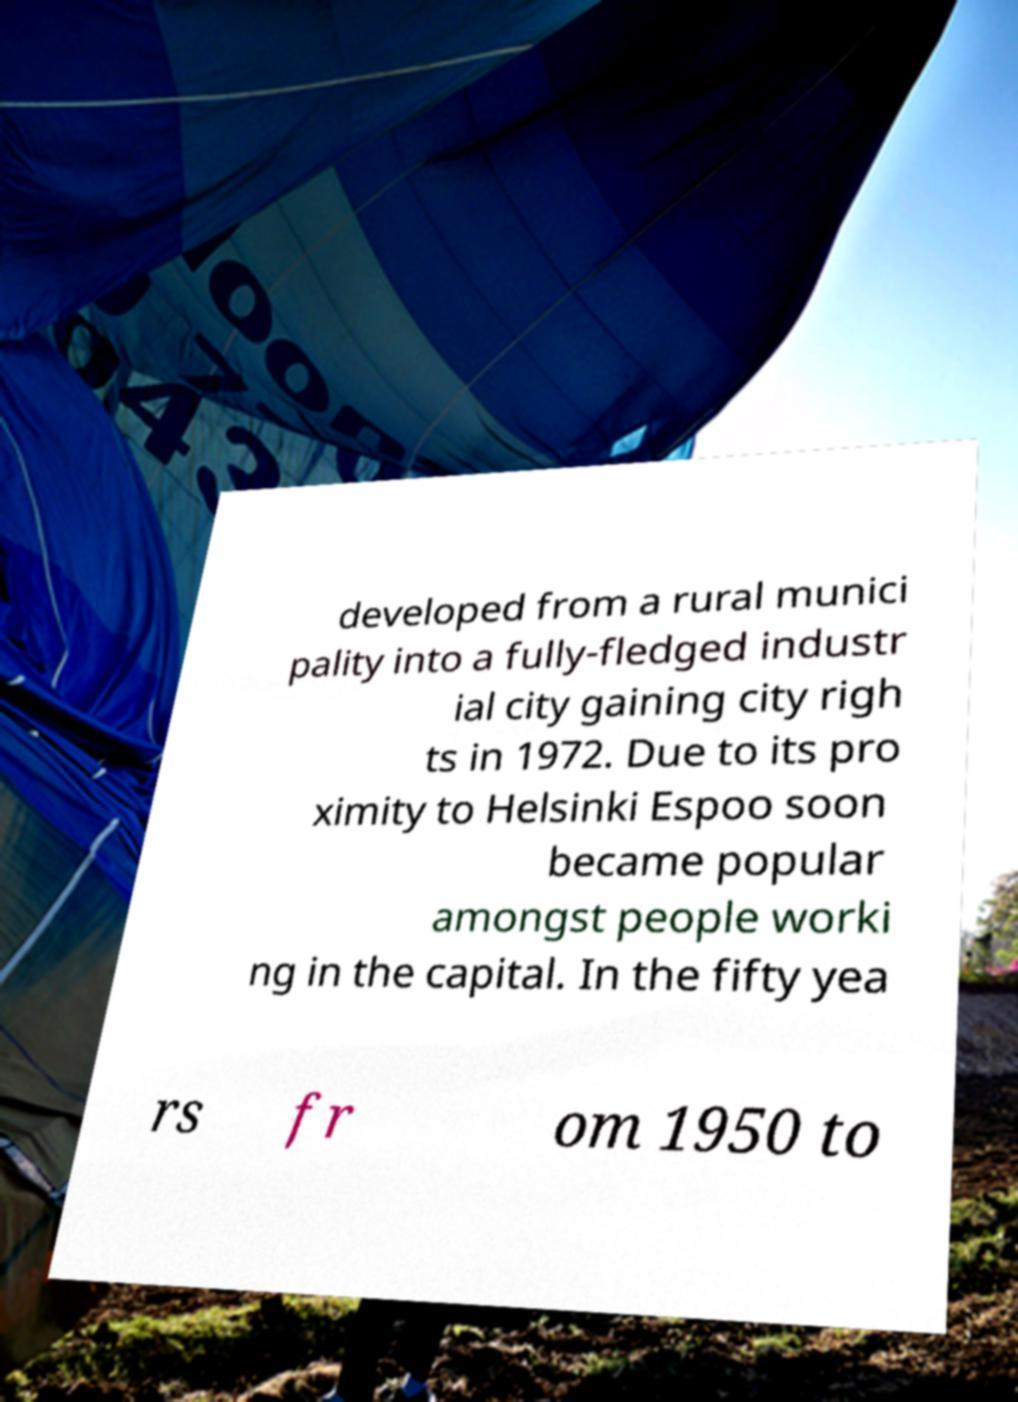Can you read and provide the text displayed in the image?This photo seems to have some interesting text. Can you extract and type it out for me? developed from a rural munici pality into a fully-fledged industr ial city gaining city righ ts in 1972. Due to its pro ximity to Helsinki Espoo soon became popular amongst people worki ng in the capital. In the fifty yea rs fr om 1950 to 